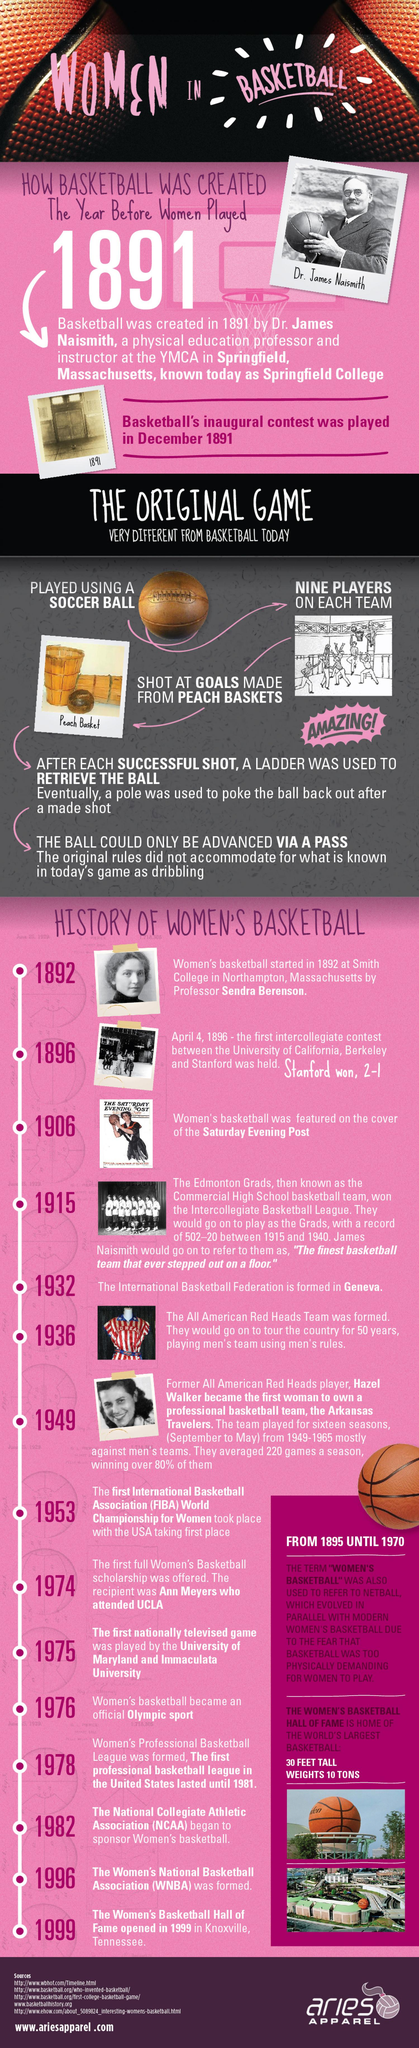Outline some significant characteristics in this image. In 1974, a scholarship was offered to women who played basketball, and this scholarship was available in 1895 and 1970 as well. 